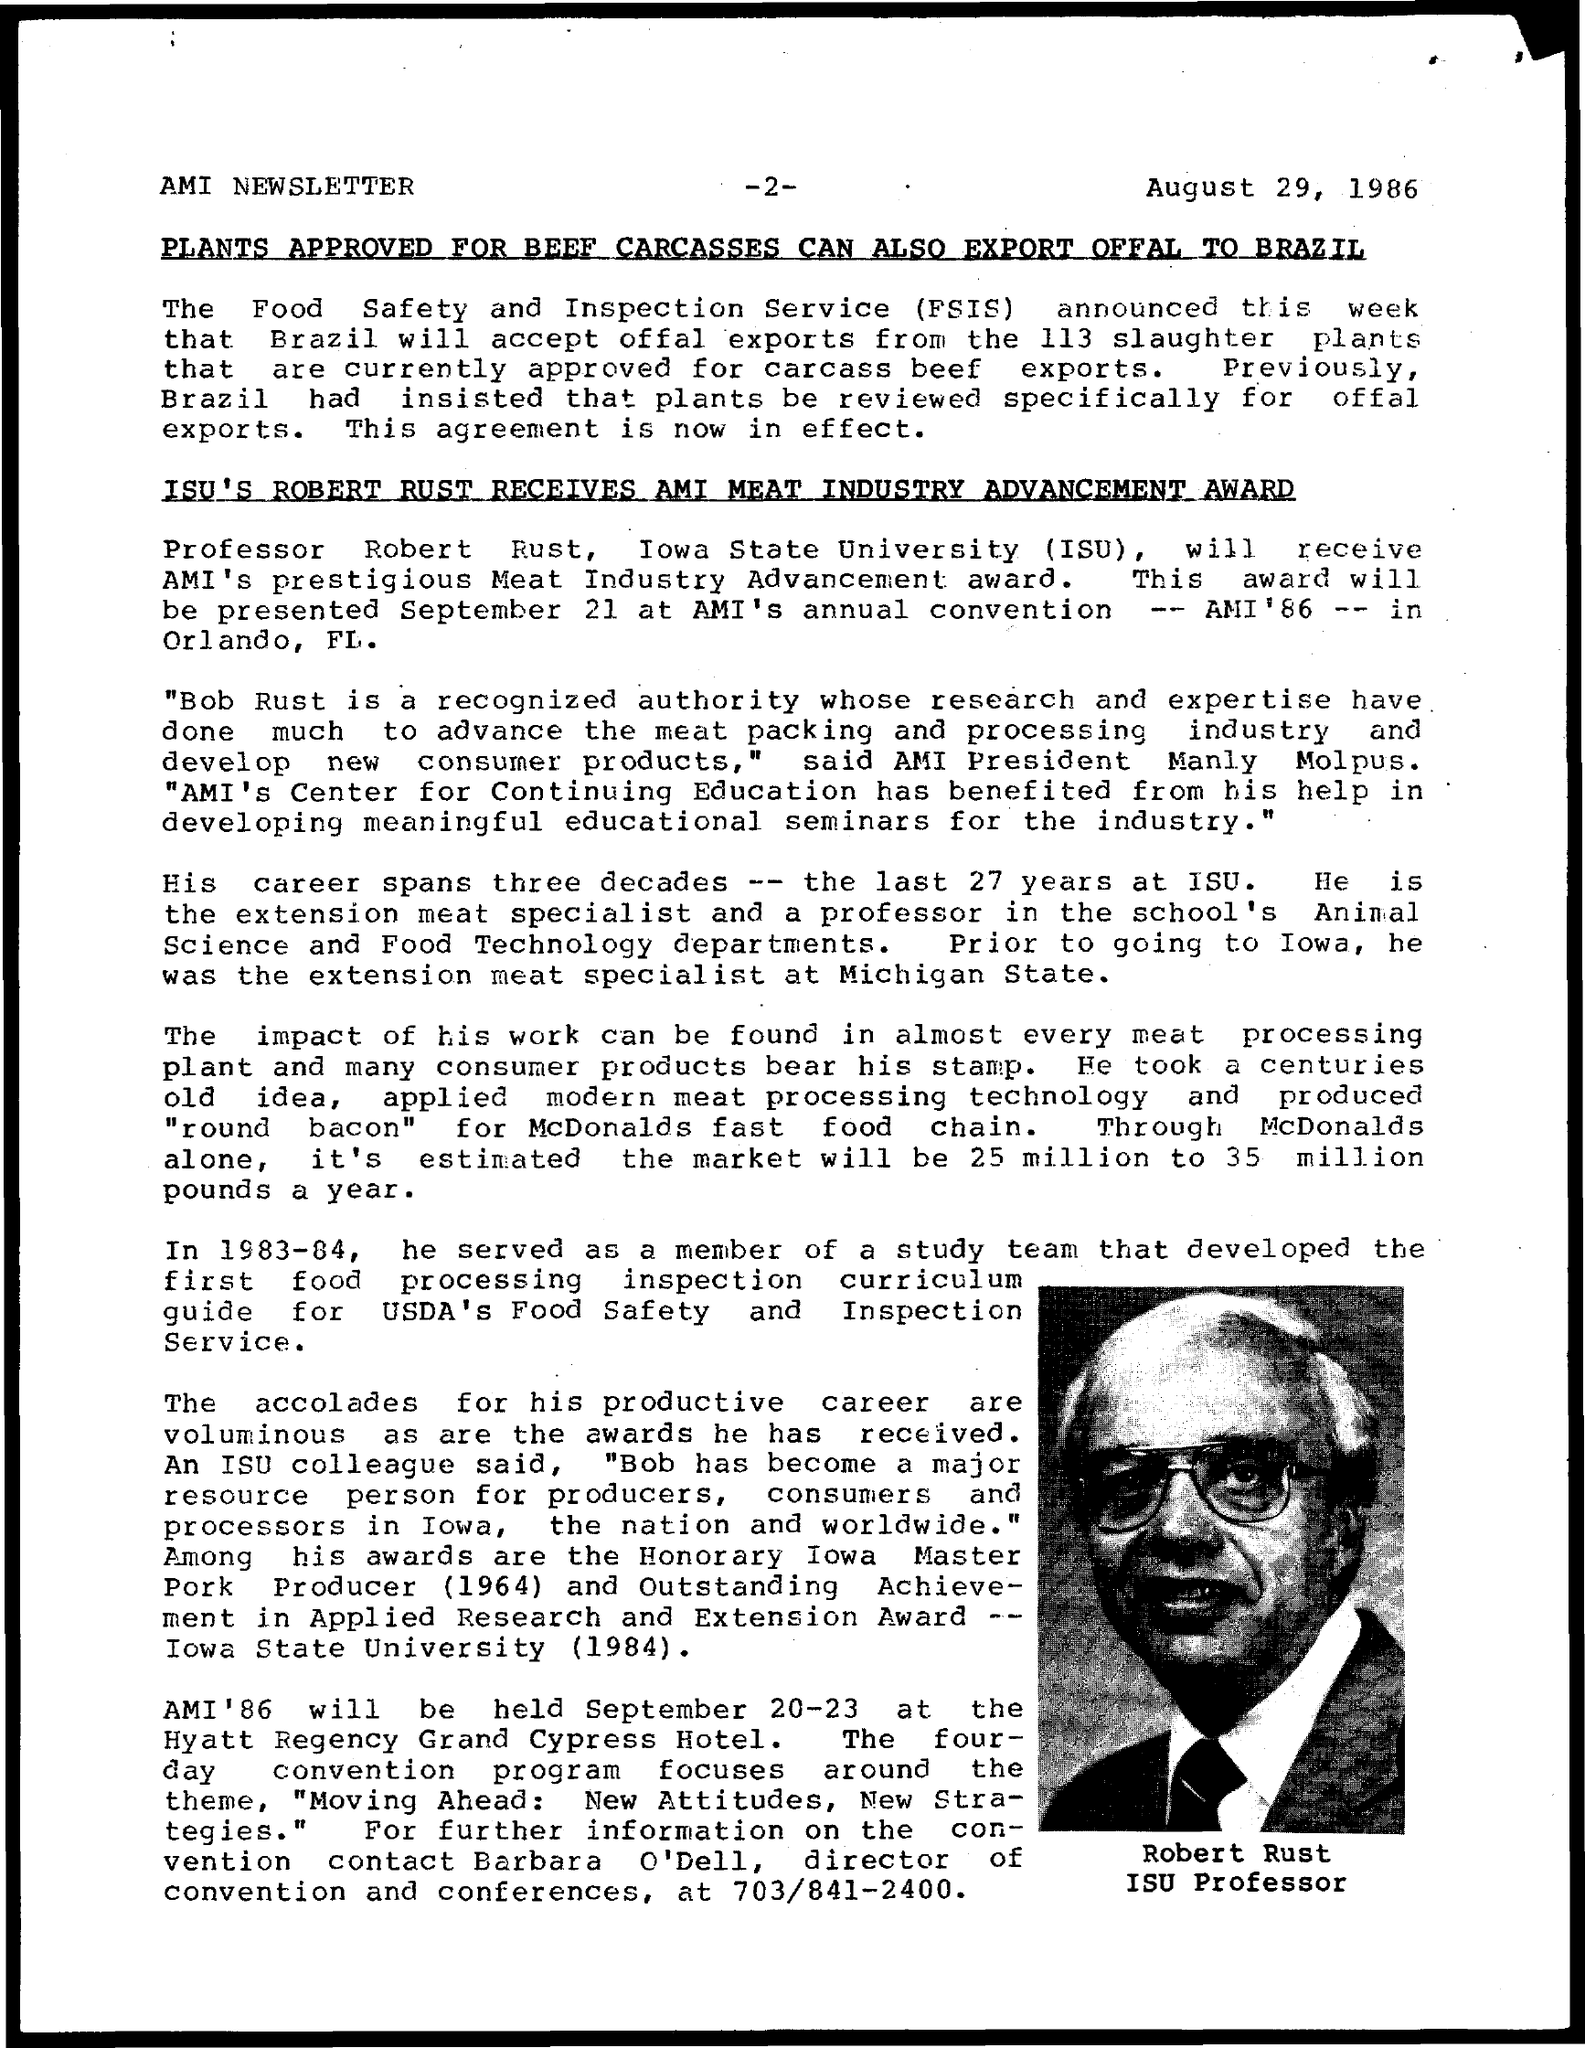Point out several critical features in this image. The date mentioned in the given page is August 29, 1986. The Food Safety and Inspection Service (FSIS) is an agency of the United States Department of Agriculture responsible for ensuring the safety and quality of the nation's food supply. The person whose name is shown on the page is Robert Rust. Iowa State University, also known as ISU, is a public research university located in Ames, Iowa, United States. It was founded in 1858 and has since grown to become one of the largest universities in the state, with a student population of over 36,000. The university offers a wide range of undergraduate, graduate, and doctoral programs in various fields, including agriculture, engineering, business, and liberal arts. ISU is well known for its research in areas such as renewable energy, biotechnology, and cybersecurity. 